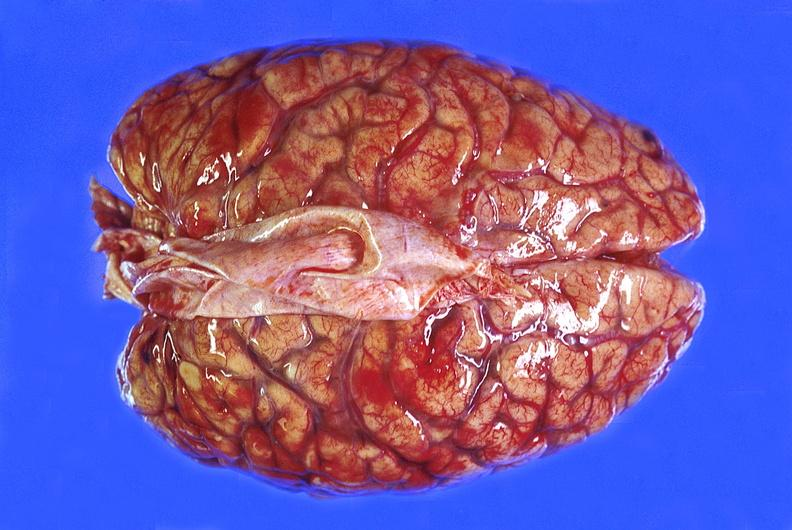does this image show brain abscess?
Answer the question using a single word or phrase. Yes 